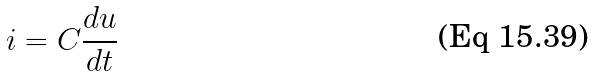Convert formula to latex. <formula><loc_0><loc_0><loc_500><loc_500>i = C \frac { d u } { d t }</formula> 